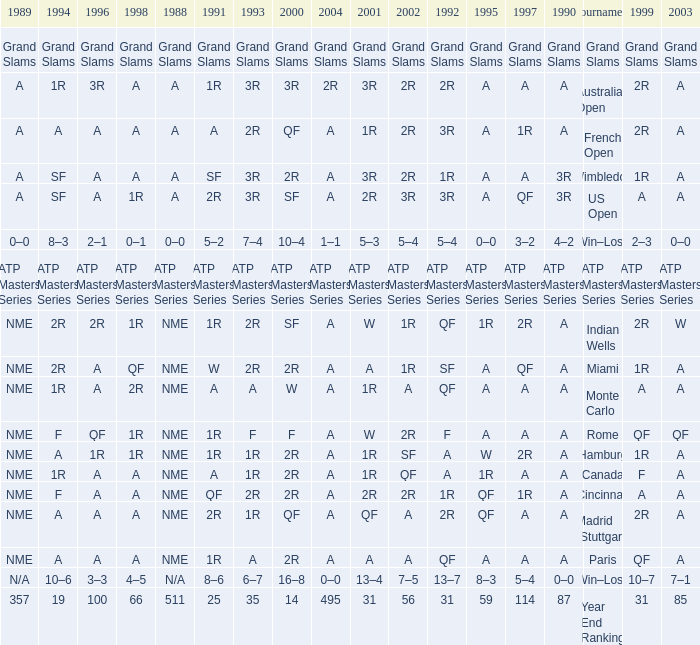What shows for 1992 when 1988 is A, at the Australian Open? 2R. 